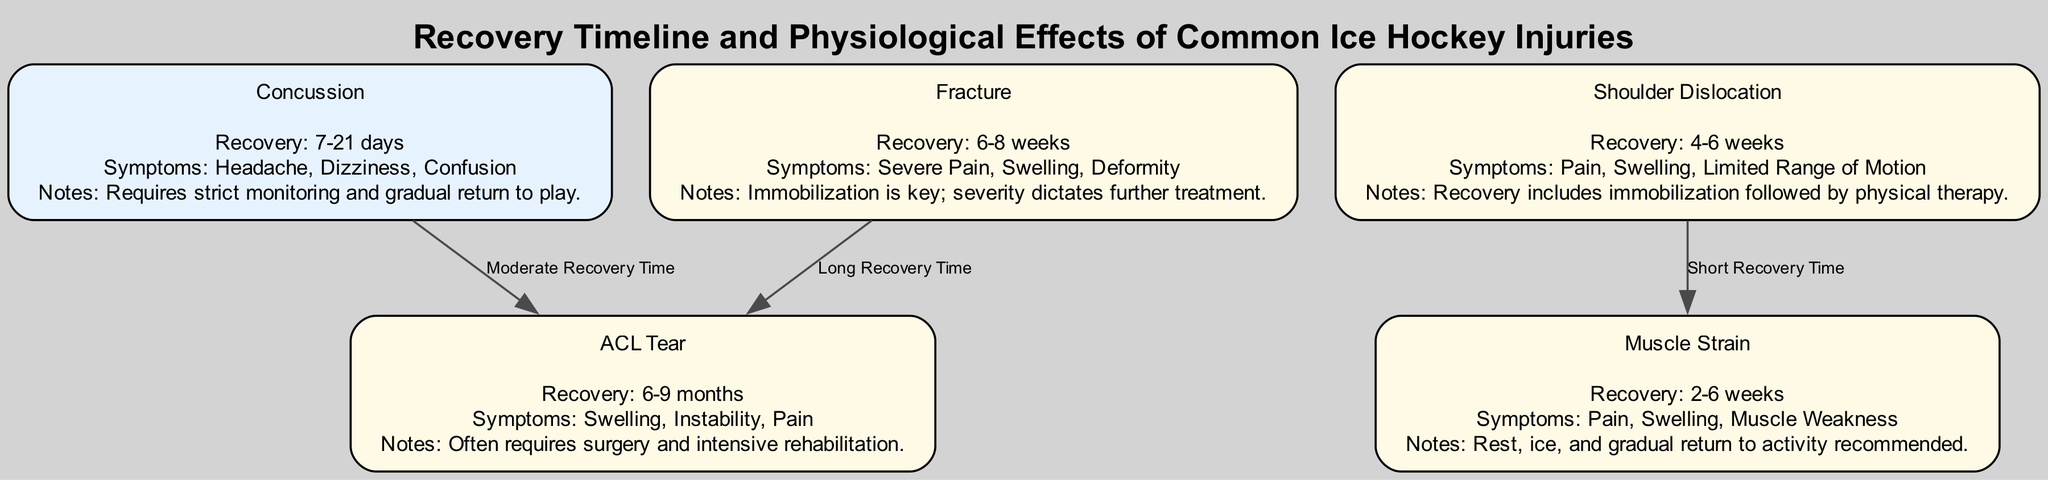What is the recovery time for a concussion? The diagram indicates that the recovery time for a concussion is specified as "7-21 days." This value is directly taken from the details associated with the "Concussion" node.
Answer: 7-21 days What symptoms are associated with an ACL tear? By examining the details under the "ACL Tear" node, we see that the symptoms listed include "Swelling," "Instability," and "Pain." These symptoms are provided in a straightforward manner within the node's details.
Answer: Swelling, Instability, Pain How many edges are present in the diagram? To determine the number of edges, we count the connections between nodes. The diagram lists three connections or edges, which can be directly seen. Thus, we arrive at the total by counting them collectively.
Answer: 3 What notes are mentioned for the recovery from a shoulder dislocation? Looking at the "Shoulder Dislocation" node, we find that the recovery notes highlight "Recovery includes immobilization followed by physical therapy." This information is sourced from the specified notes within that node.
Answer: Recovery includes immobilization followed by physical therapy What is the relationship in recovery time between a fracture and an ACL tear? The diagram specifies a connection from the "Fracture" node to the "ACL Tear" node labeled as "Long Recovery Time." This implies that recovery from a fracture is comparatively longer than that for an ACL tear.
Answer: Long Recovery Time What is the recovery duration for a muscle strain? The recovery time for a muscle strain is noted in the diagram as "2-6 weeks," which is explicitly mentioned in the details of the respective node, allowing for a direct answer based on those specified values.
Answer: 2-6 weeks Which injury has the shortest recovery time? The node details indicate that "Shoulder Dislocation" has a recovery time of "4-6 weeks," which is shorter than all other injuries represented in the diagram. Therefore, it is reasonable to conclude from the comparisons that this has the shortest recovery time.
Answer: Shoulder Dislocation What can be inferred about the relationship between a concussion and an ACL tear? The diagram indicates a connection between the "Concussion" and "ACL Tear" nodes, labeled as "Moderate Recovery Time." This suggests that the recovery time for a concussion is less compared to the recovery duration for an ACL tear, which is much longer. Thus, the inference reflects a comparative nature of recovery time.
Answer: Moderate Recovery Time 